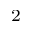<formula> <loc_0><loc_0><loc_500><loc_500>^ { 2 }</formula> 